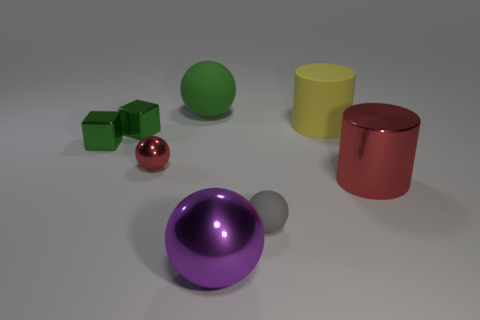Is the size of the purple metal thing on the left side of the red cylinder the same as the matte cylinder?
Your response must be concise. Yes. How many matte objects are yellow cylinders or large cyan balls?
Offer a very short reply. 1. There is a red shiny object that is left of the big green matte object; what size is it?
Make the answer very short. Small. Do the yellow rubber thing and the large red metallic object have the same shape?
Your answer should be compact. Yes. What number of big objects are purple balls or matte balls?
Offer a very short reply. 2. Are there any small balls on the right side of the matte cylinder?
Your answer should be very brief. No. Are there the same number of small green cubes in front of the big red shiny thing and large blue matte cylinders?
Keep it short and to the point. Yes. The gray thing that is the same shape as the small red metal thing is what size?
Your answer should be compact. Small. There is a big red metallic object; does it have the same shape as the tiny thing that is right of the red ball?
Your response must be concise. No. What size is the ball that is on the right side of the big purple metallic ball on the right side of the large green thing?
Your answer should be compact. Small. 